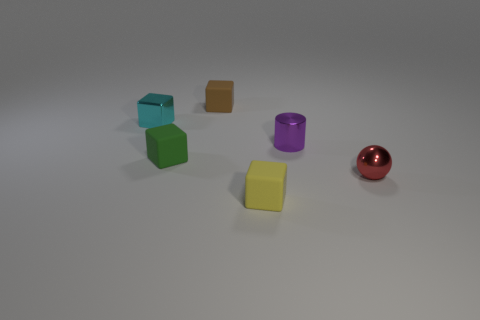Subtract 1 cubes. How many cubes are left? 3 Add 3 tiny green matte objects. How many objects exist? 9 Subtract all cylinders. How many objects are left? 5 Subtract all small cyan blocks. Subtract all tiny metal cylinders. How many objects are left? 4 Add 4 small yellow matte cubes. How many small yellow matte cubes are left? 5 Add 2 blue matte things. How many blue matte things exist? 2 Subtract 0 gray balls. How many objects are left? 6 